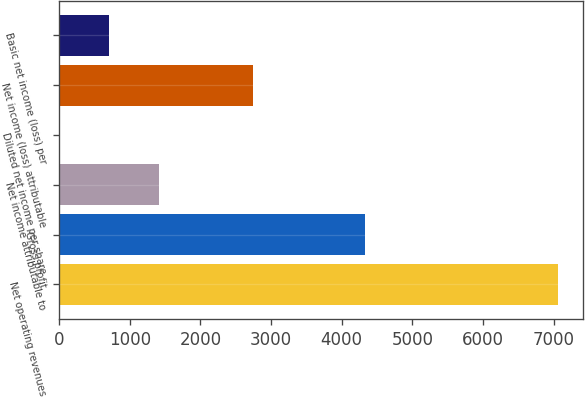Convert chart to OTSL. <chart><loc_0><loc_0><loc_500><loc_500><bar_chart><fcel>Net operating revenues<fcel>Gross profit<fcel>Net income attributable to<fcel>Diluted net income per share<fcel>Net income (loss) attributable<fcel>Basic net income (loss) per<nl><fcel>7058<fcel>4337<fcel>1411.76<fcel>0.2<fcel>2752<fcel>705.98<nl></chart> 